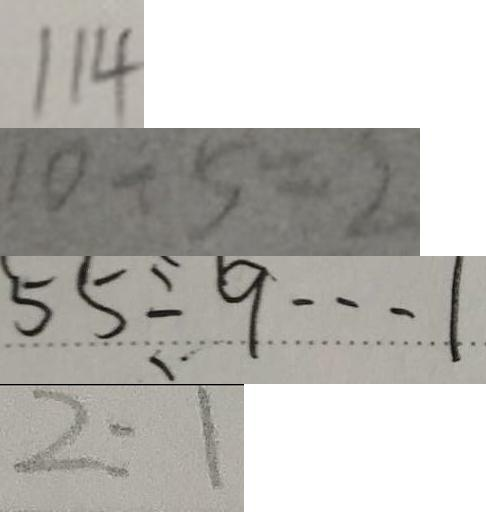Convert formula to latex. <formula><loc_0><loc_0><loc_500><loc_500>1 1 4 
 1 0 \div 5 = 2 
 5 5 \div 9 \cdots 1 
 2 : 1</formula> 